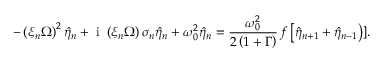<formula> <loc_0><loc_0><loc_500><loc_500>- \left ( \xi _ { n } \Omega \right ) ^ { 2 } \hat { \eta } _ { n } + i \left ( \xi _ { n } \Omega \right ) \sigma _ { n } \hat { \eta } _ { n } + \omega _ { 0 } ^ { 2 } \hat { \eta } _ { n } = \frac { \omega _ { 0 } ^ { 2 } } { 2 \left ( 1 + \Gamma \right ) } \, f \left [ \hat { \eta } _ { n + 1 } + \hat { \eta } _ { n - 1 } \right ) ] .</formula> 